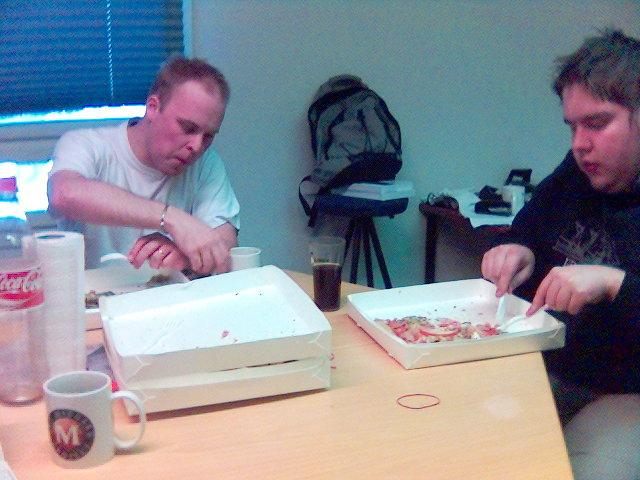What type of beverages are being consumed by the pizza eater? coca cola 